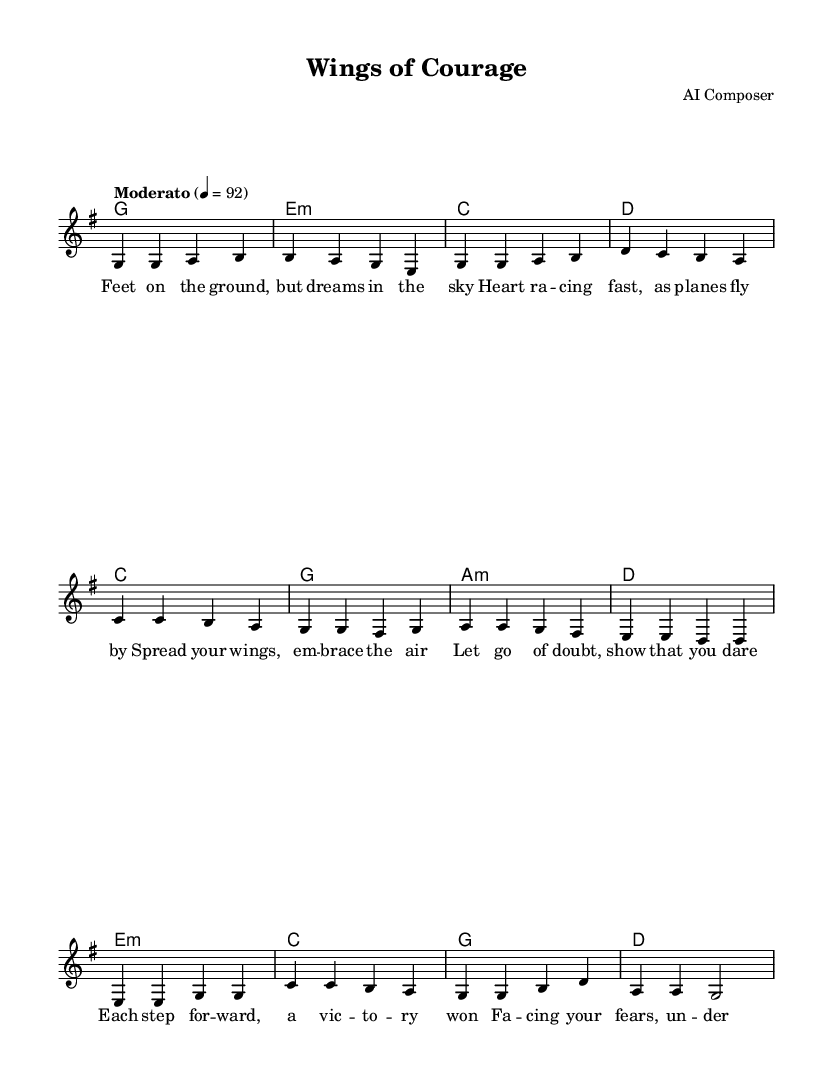What is the key signature of this music? The key signature is G major, which has one sharp (F#). This can be identified from the 'g' indicated at the top of the score under the global section.
Answer: G major What is the time signature of this music? The time signature is 4/4, which is displayed prominently in the music sheet under the global section. This indicates that there are four beats in each measure.
Answer: 4/4 What is the tempo marking indicated in this music? The tempo marking is "Moderato" at a tempo of quarter note = 92. This is noted in the global section, specifying the speed at which the piece should be played.
Answer: Moderato, quarter note = 92 How many measures are in the verse section? The verse section consists of four measures, as indicated by the organization of the notes and their corresponding lengths. Each group of notes divided by vertical lines represents a measure, totaling to four in this section.
Answer: 4 What is the overall lyrical theme of this piece? The overall lyrical theme revolves around finding courage and confronting fears, as depicted in the lyrics, which mention overcoming doubt and embracing the skies. This encompasses personal growth and inner peace, central to the message of the music.
Answer: Courage and overcoming fears What type of chords are used in the guitar part? The guitar part utilizes major and minor chords, including G major, E minor, C major, and D major. This combination of chords contributes to the folk acoustic style and the emotional tone of the piece.
Answer: Major and minor chords What does the bridge section of the music convey? The bridge section conveys a shift in the emotional landscape, building on the themes established in the verse and chorus. Here, it uses a different melodic pattern to create a sense of elevation and reflection, emphasizing the journey of overcoming fears.
Answer: Built on reflecting and overcoming fears 